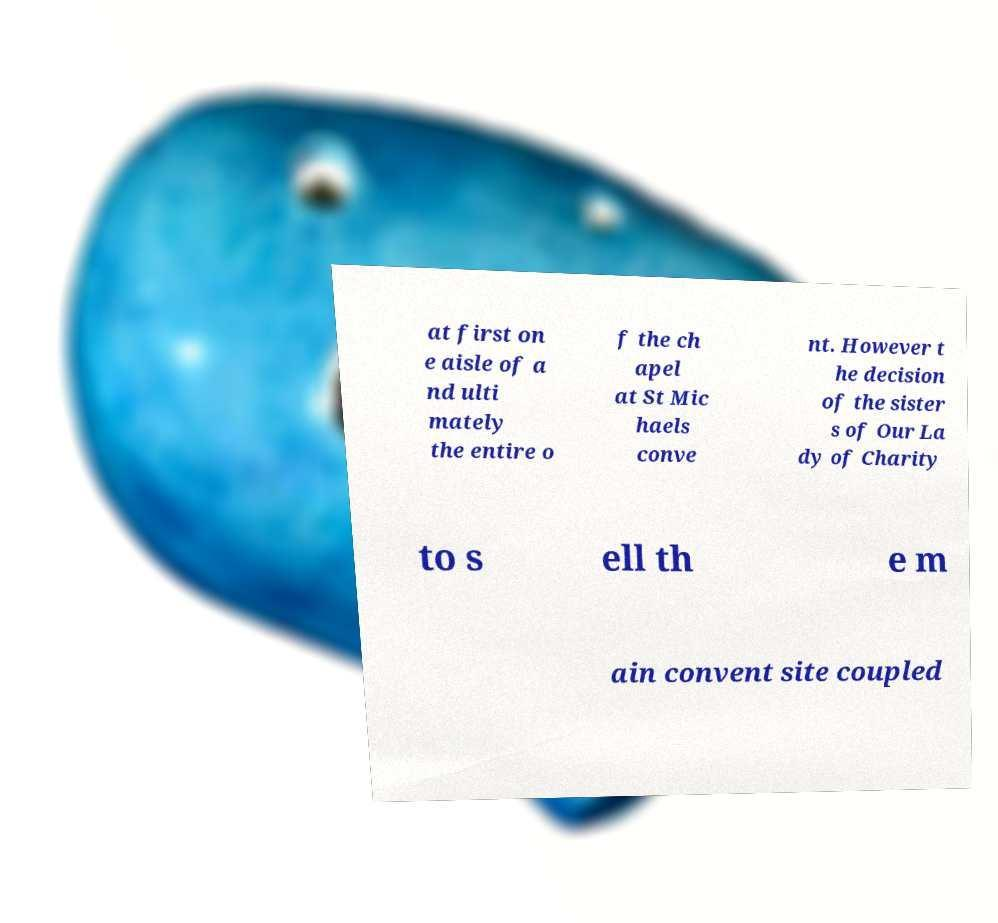Could you extract and type out the text from this image? at first on e aisle of a nd ulti mately the entire o f the ch apel at St Mic haels conve nt. However t he decision of the sister s of Our La dy of Charity to s ell th e m ain convent site coupled 